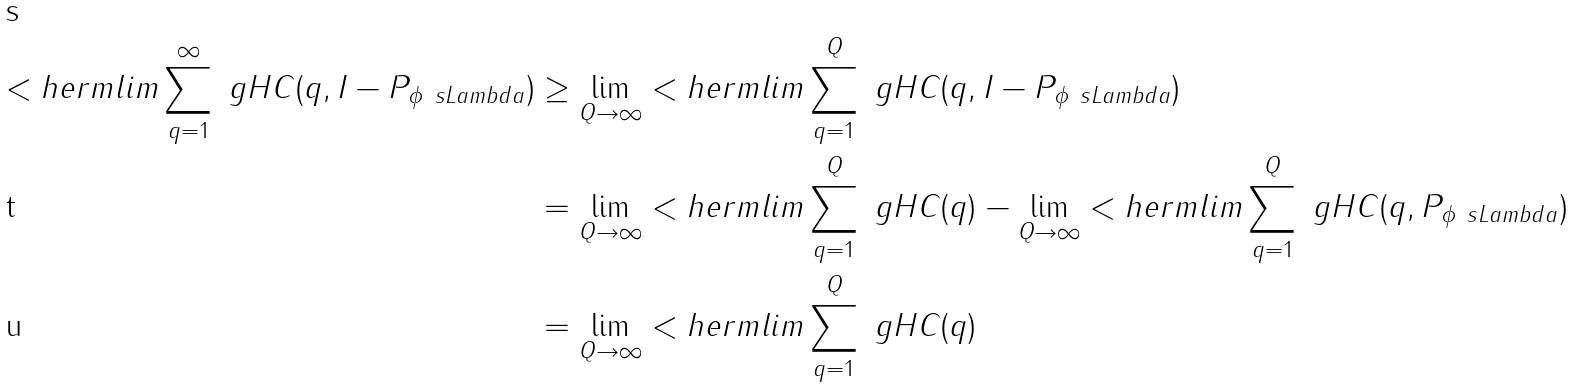<formula> <loc_0><loc_0><loc_500><loc_500>< h e r m l i m \sum _ { q = 1 } ^ { \infty } \ g H C ( q , I - P _ { \phi _ { \ } s L a m b d a } ) & \geq \lim _ { Q \to \infty } < h e r m l i m \sum _ { q = 1 } ^ { Q } \ g H C ( q , I - P _ { \phi _ { \ } s L a m b d a } ) \\ & = \lim _ { Q \to \infty } < h e r m l i m \sum _ { q = 1 } ^ { Q } \ g H C ( q ) - \lim _ { Q \to \infty } < h e r m l i m \sum _ { q = 1 } ^ { Q } \ g H C ( q , P _ { \phi _ { \ } s L a m b d a } ) \\ & = \lim _ { Q \to \infty } < h e r m l i m \sum _ { q = 1 } ^ { Q } \ g H C ( q )</formula> 